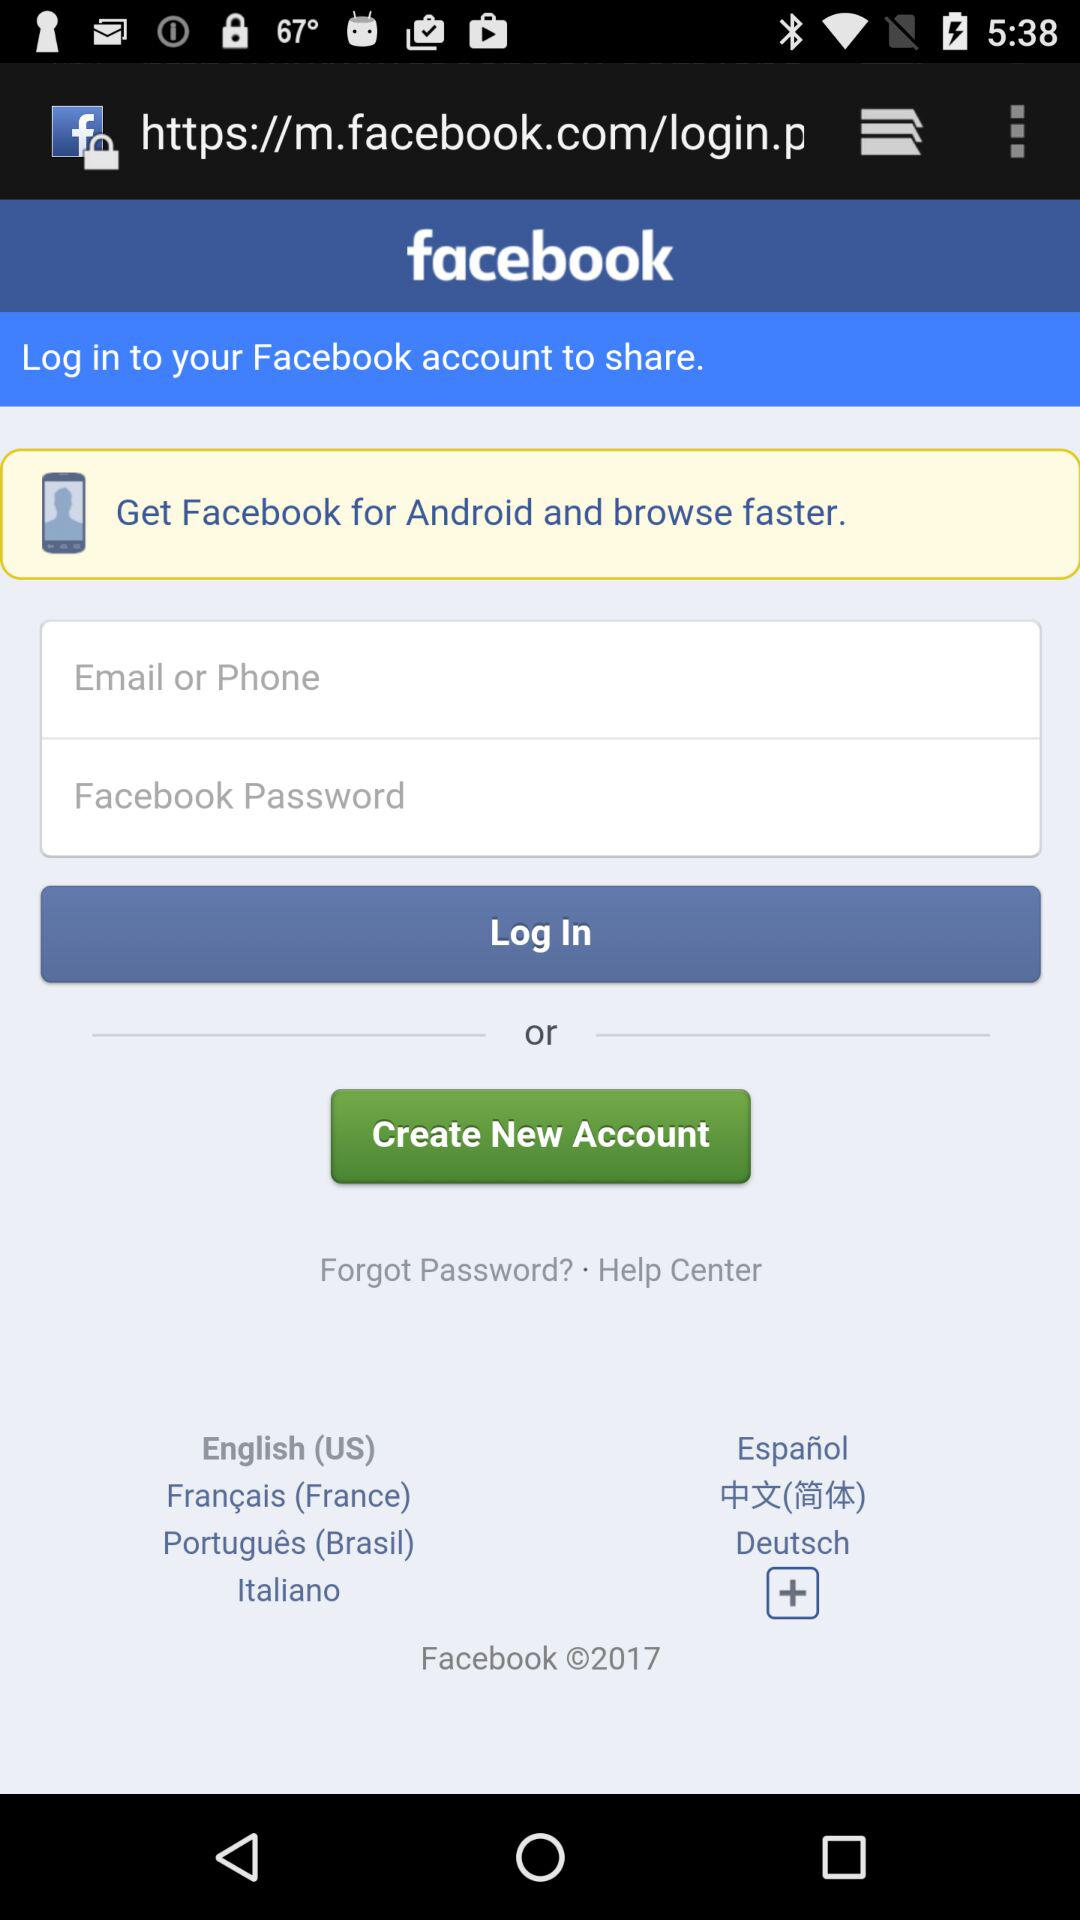How many characters are required to create a password?
When the provided information is insufficient, respond with <no answer>. <no answer> 